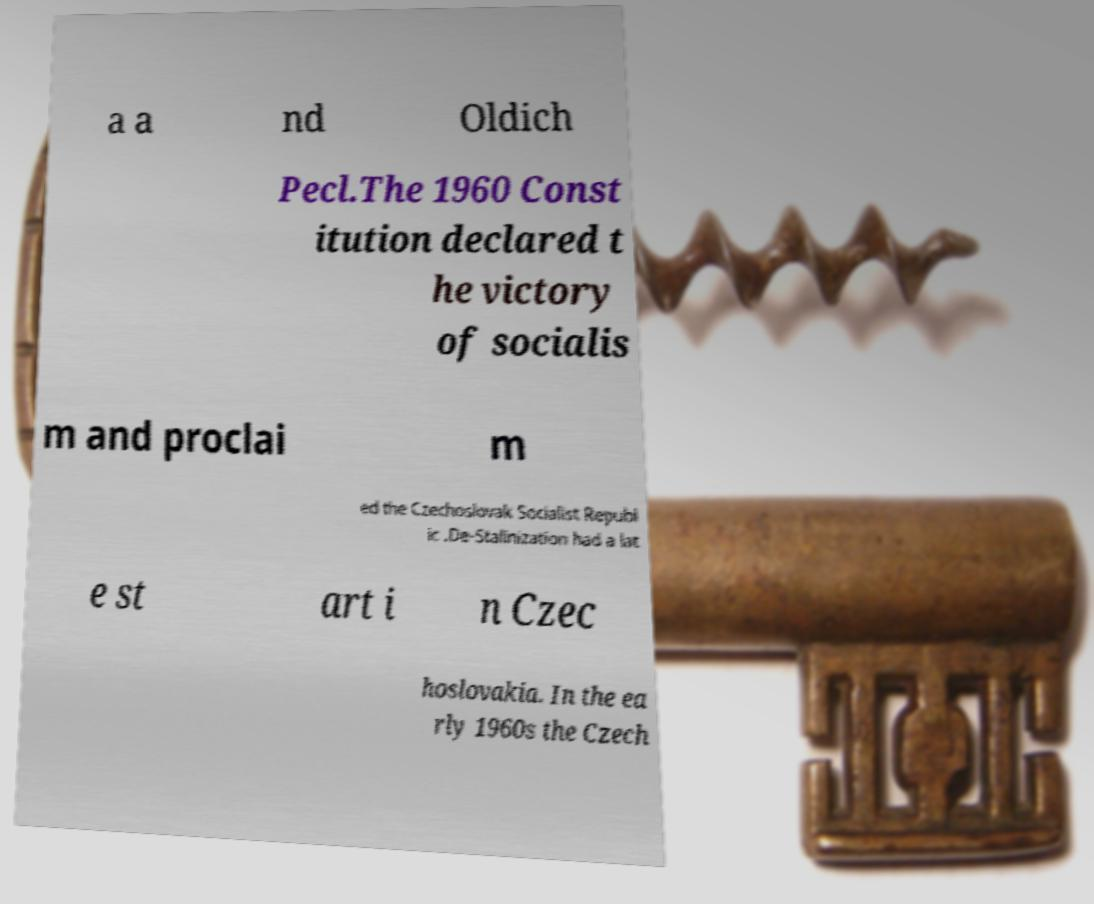For documentation purposes, I need the text within this image transcribed. Could you provide that? a a nd Oldich Pecl.The 1960 Const itution declared t he victory of socialis m and proclai m ed the Czechoslovak Socialist Republ ic .De-Stalinization had a lat e st art i n Czec hoslovakia. In the ea rly 1960s the Czech 